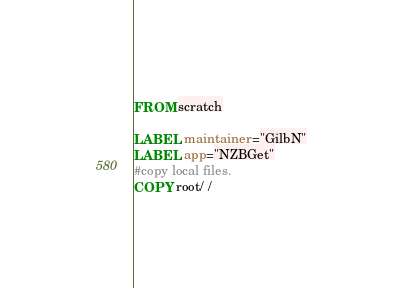<code> <loc_0><loc_0><loc_500><loc_500><_Dockerfile_>FROM scratch

LABEL maintainer="GilbN" 
LABEL app="NZBGet"
#copy local files. 
COPY root/ /</code> 